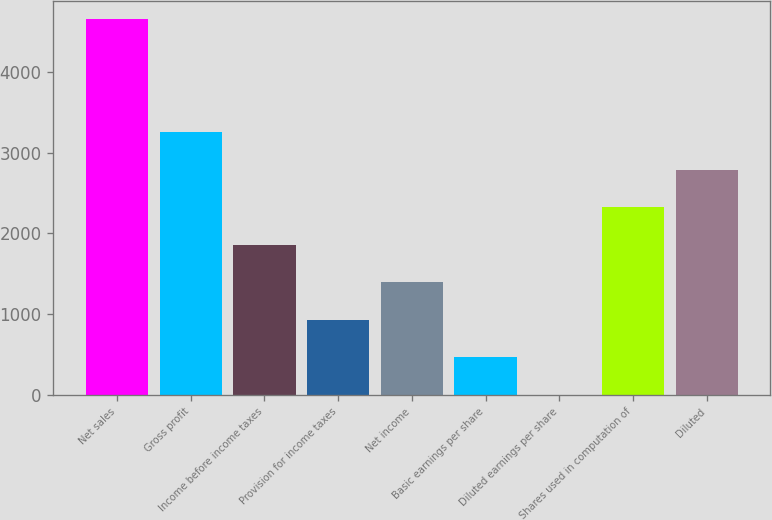<chart> <loc_0><loc_0><loc_500><loc_500><bar_chart><fcel>Net sales<fcel>Gross profit<fcel>Income before income taxes<fcel>Provision for income taxes<fcel>Net income<fcel>Basic earnings per share<fcel>Diluted earnings per share<fcel>Shares used in computation of<fcel>Diluted<nl><fcel>4651<fcel>3255.81<fcel>1860.6<fcel>930.46<fcel>1395.53<fcel>465.39<fcel>0.32<fcel>2325.67<fcel>2790.74<nl></chart> 